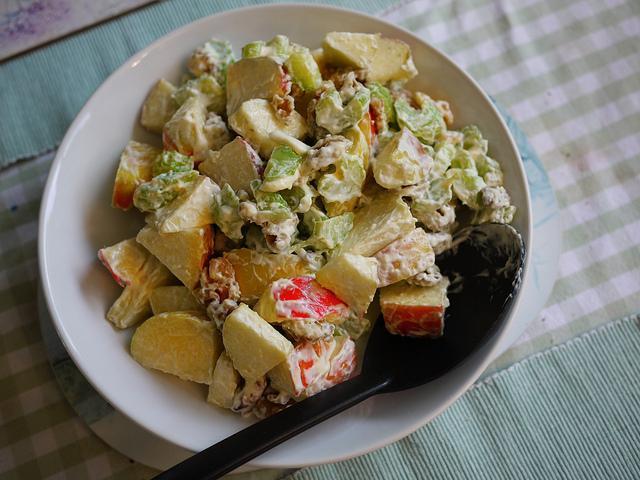How many apples are in the photo?
Give a very brief answer. 8. 